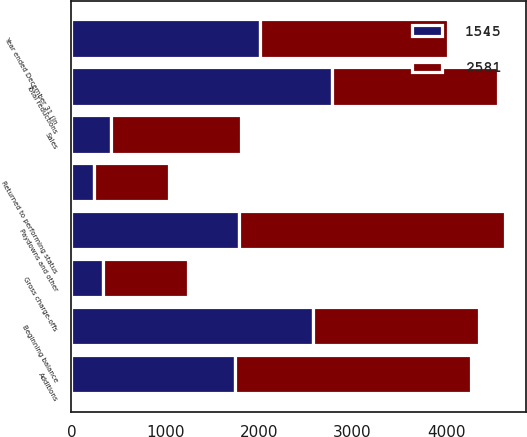Convert chart. <chart><loc_0><loc_0><loc_500><loc_500><stacked_bar_chart><ecel><fcel>Year ended December 31 (in<fcel>Beginning balance<fcel>Additions<fcel>Paydowns and other<fcel>Gross charge-offs<fcel>Returned to performing status<fcel>Sales<fcel>Total reductions<nl><fcel>1545<fcel>2012<fcel>2581<fcel>1748<fcel>1784<fcel>335<fcel>240<fcel>425<fcel>2784<nl><fcel>2581<fcel>2011<fcel>1766<fcel>2519<fcel>2841<fcel>907<fcel>807<fcel>1389<fcel>1766<nl></chart> 